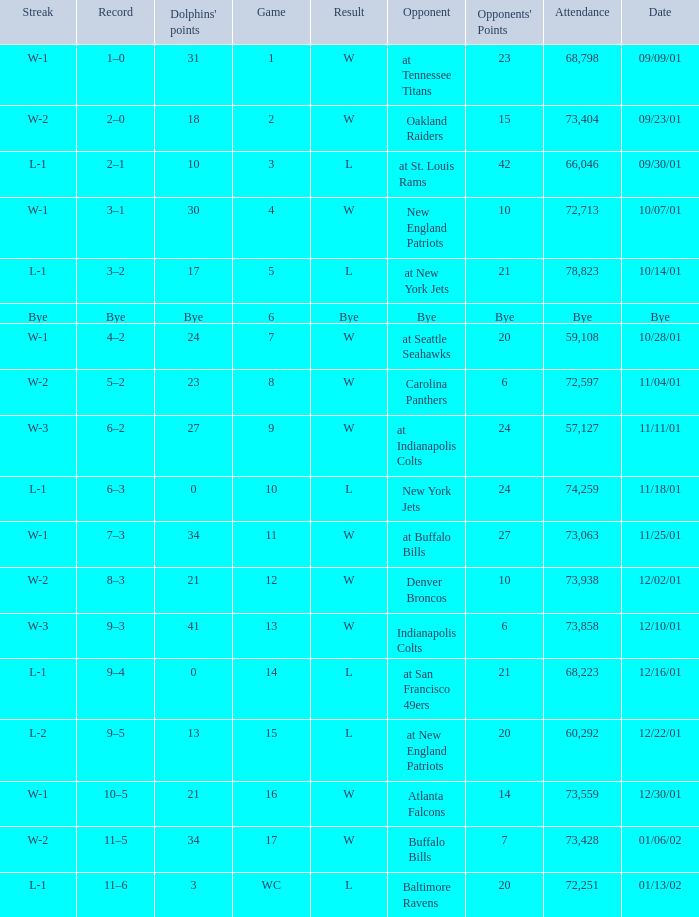What is the streak for game 16 when the Dolphins had 21 points? W-1. 